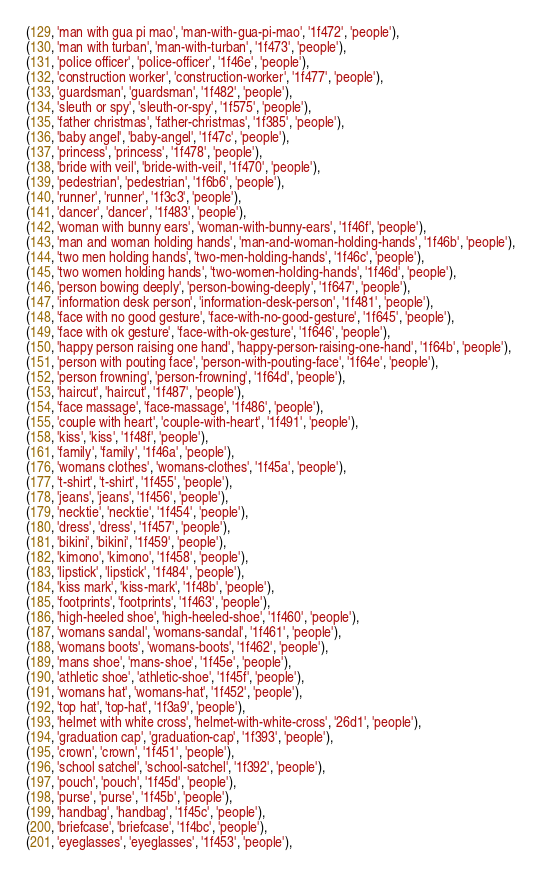<code> <loc_0><loc_0><loc_500><loc_500><_SQL_>(129, 'man with gua pi mao', 'man-with-gua-pi-mao', '1f472', 'people'),
(130, 'man with turban', 'man-with-turban', '1f473', 'people'),
(131, 'police officer', 'police-officer', '1f46e', 'people'),
(132, 'construction worker', 'construction-worker', '1f477', 'people'),
(133, 'guardsman', 'guardsman', '1f482', 'people'),
(134, 'sleuth or spy', 'sleuth-or-spy', '1f575', 'people'),
(135, 'father christmas', 'father-christmas', '1f385', 'people'),
(136, 'baby angel', 'baby-angel', '1f47c', 'people'),
(137, 'princess', 'princess', '1f478', 'people'),
(138, 'bride with veil', 'bride-with-veil', '1f470', 'people'),
(139, 'pedestrian', 'pedestrian', '1f6b6', 'people'),
(140, 'runner', 'runner', '1f3c3', 'people'),
(141, 'dancer', 'dancer', '1f483', 'people'),
(142, 'woman with bunny ears', 'woman-with-bunny-ears', '1f46f', 'people'),
(143, 'man and woman holding hands', 'man-and-woman-holding-hands', '1f46b', 'people'),
(144, 'two men holding hands', 'two-men-holding-hands', '1f46c', 'people'),
(145, 'two women holding hands', 'two-women-holding-hands', '1f46d', 'people'),
(146, 'person bowing deeply', 'person-bowing-deeply', '1f647', 'people'),
(147, 'information desk person', 'information-desk-person', '1f481', 'people'),
(148, 'face with no good gesture', 'face-with-no-good-gesture', '1f645', 'people'),
(149, 'face with ok gesture', 'face-with-ok-gesture', '1f646', 'people'),
(150, 'happy person raising one hand', 'happy-person-raising-one-hand', '1f64b', 'people'),
(151, 'person with pouting face', 'person-with-pouting-face', '1f64e', 'people'),
(152, 'person frowning', 'person-frowning', '1f64d', 'people'),
(153, 'haircut', 'haircut', '1f487', 'people'),
(154, 'face massage', 'face-massage', '1f486', 'people'),
(155, 'couple with heart', 'couple-with-heart', '1f491', 'people'),
(158, 'kiss', 'kiss', '1f48f', 'people'),
(161, 'family', 'family', '1f46a', 'people'),
(176, 'womans clothes', 'womans-clothes', '1f45a', 'people'),
(177, 't-shirt', 't-shirt', '1f455', 'people'),
(178, 'jeans', 'jeans', '1f456', 'people'),
(179, 'necktie', 'necktie', '1f454', 'people'),
(180, 'dress', 'dress', '1f457', 'people'),
(181, 'bikini', 'bikini', '1f459', 'people'),
(182, 'kimono', 'kimono', '1f458', 'people'),
(183, 'lipstick', 'lipstick', '1f484', 'people'),
(184, 'kiss mark', 'kiss-mark', '1f48b', 'people'),
(185, 'footprints', 'footprints', '1f463', 'people'),
(186, 'high-heeled shoe', 'high-heeled-shoe', '1f460', 'people'),
(187, 'womans sandal', 'womans-sandal', '1f461', 'people'),
(188, 'womans boots', 'womans-boots', '1f462', 'people'),
(189, 'mans shoe', 'mans-shoe', '1f45e', 'people'),
(190, 'athletic shoe', 'athletic-shoe', '1f45f', 'people'),
(191, 'womans hat', 'womans-hat', '1f452', 'people'),
(192, 'top hat', 'top-hat', '1f3a9', 'people'),
(193, 'helmet with white cross', 'helmet-with-white-cross', '26d1', 'people'),
(194, 'graduation cap', 'graduation-cap', '1f393', 'people'),
(195, 'crown', 'crown', '1f451', 'people'),
(196, 'school satchel', 'school-satchel', '1f392', 'people'),
(197, 'pouch', 'pouch', '1f45d', 'people'),
(198, 'purse', 'purse', '1f45b', 'people'),
(199, 'handbag', 'handbag', '1f45c', 'people'),
(200, 'briefcase', 'briefcase', '1f4bc', 'people'),
(201, 'eyeglasses', 'eyeglasses', '1f453', 'people'),</code> 